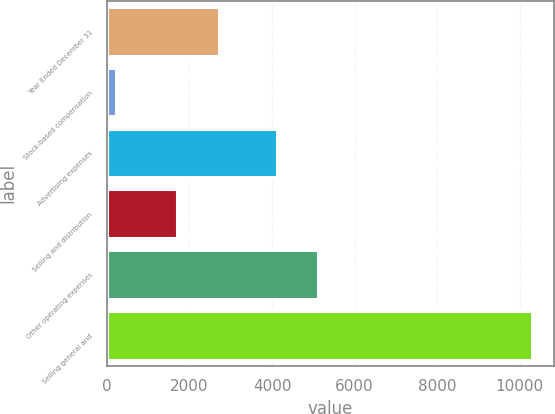Convert chart. <chart><loc_0><loc_0><loc_500><loc_500><bar_chart><fcel>Year Ended December 31<fcel>Stock-based compensation<fcel>Advertising expenses<fcel>Selling and distribution<fcel>Other operating expenses<fcel>Selling general and<nl><fcel>2709.2<fcel>225<fcel>4113<fcel>1701<fcel>5121.2<fcel>10307<nl></chart> 